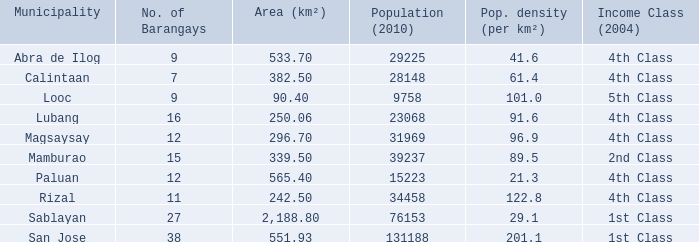Provide the number of people per square kilometer in calintaan city. 61.4. 